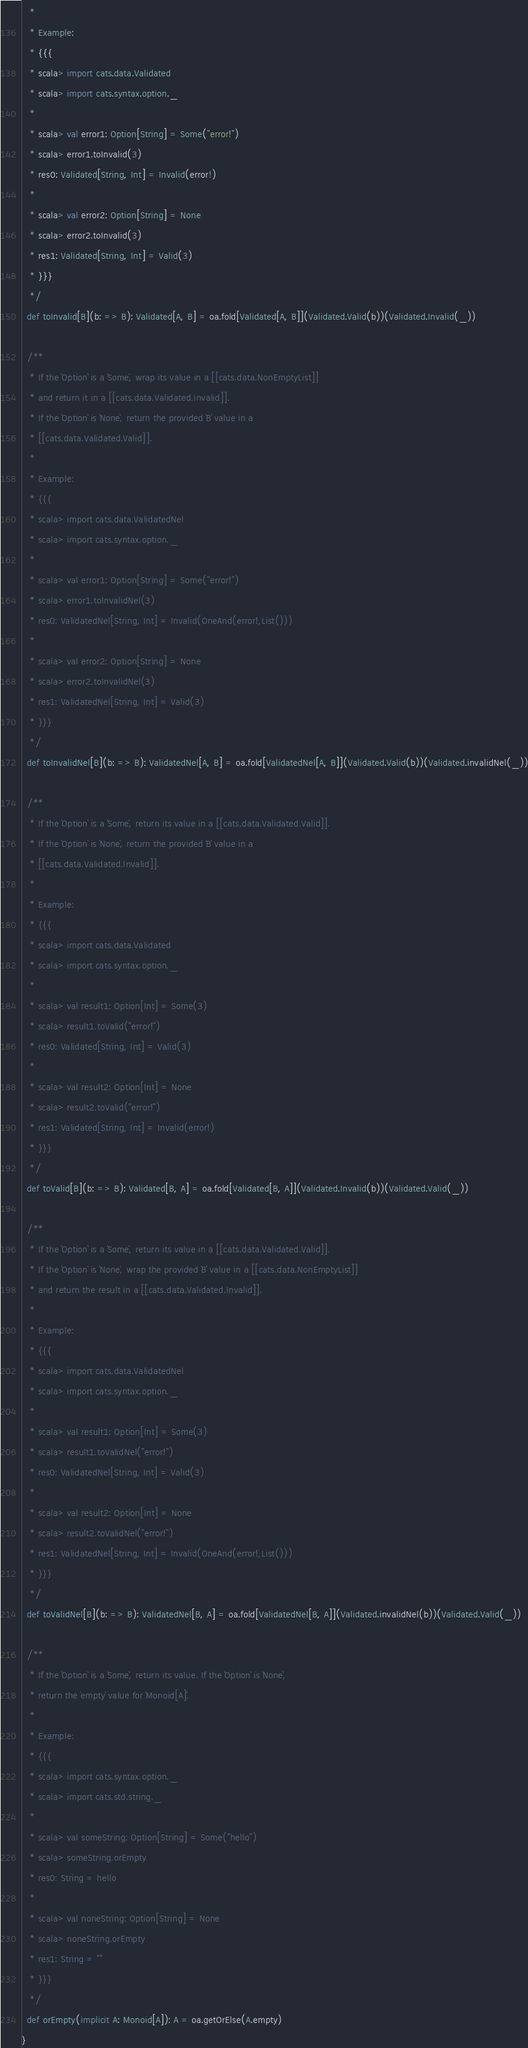Convert code to text. <code><loc_0><loc_0><loc_500><loc_500><_Scala_>   *
   * Example:
   * {{{
   * scala> import cats.data.Validated
   * scala> import cats.syntax.option._
   *
   * scala> val error1: Option[String] = Some("error!")
   * scala> error1.toInvalid(3)
   * res0: Validated[String, Int] = Invalid(error!)
   *
   * scala> val error2: Option[String] = None
   * scala> error2.toInvalid(3)
   * res1: Validated[String, Int] = Valid(3)
   * }}}
   */
  def toInvalid[B](b: => B): Validated[A, B] = oa.fold[Validated[A, B]](Validated.Valid(b))(Validated.Invalid(_))

  /**
   * If the `Option` is a `Some`, wrap its value in a [[cats.data.NonEmptyList]]
   * and return it in a [[cats.data.Validated.Invalid]].
   * If the `Option` is `None`, return the provided `B` value in a
   * [[cats.data.Validated.Valid]].
   *
   * Example:
   * {{{
   * scala> import cats.data.ValidatedNel
   * scala> import cats.syntax.option._
   *
   * scala> val error1: Option[String] = Some("error!")
   * scala> error1.toInvalidNel(3)
   * res0: ValidatedNel[String, Int] = Invalid(OneAnd(error!,List()))
   *
   * scala> val error2: Option[String] = None
   * scala> error2.toInvalidNel(3)
   * res1: ValidatedNel[String, Int] = Valid(3)
   * }}}
   */
  def toInvalidNel[B](b: => B): ValidatedNel[A, B] = oa.fold[ValidatedNel[A, B]](Validated.Valid(b))(Validated.invalidNel(_))

  /**
   * If the `Option` is a `Some`, return its value in a [[cats.data.Validated.Valid]].
   * If the `Option` is `None`, return the provided `B` value in a
   * [[cats.data.Validated.Invalid]].
   *
   * Example:
   * {{{
   * scala> import cats.data.Validated
   * scala> import cats.syntax.option._
   *
   * scala> val result1: Option[Int] = Some(3)
   * scala> result1.toValid("error!")
   * res0: Validated[String, Int] = Valid(3)
   *
   * scala> val result2: Option[Int] = None
   * scala> result2.toValid("error!")
   * res1: Validated[String, Int] = Invalid(error!)
   * }}}
   */
  def toValid[B](b: => B): Validated[B, A] = oa.fold[Validated[B, A]](Validated.Invalid(b))(Validated.Valid(_))

  /**
   * If the `Option` is a `Some`, return its value in a [[cats.data.Validated.Valid]].
   * If the `Option` is `None`, wrap the provided `B` value in a [[cats.data.NonEmptyList]]
   * and return the result in a [[cats.data.Validated.Invalid]].
   *
   * Example:
   * {{{
   * scala> import cats.data.ValidatedNel
   * scala> import cats.syntax.option._
   *
   * scala> val result1: Option[Int] = Some(3)
   * scala> result1.toValidNel("error!")
   * res0: ValidatedNel[String, Int] = Valid(3)
   *
   * scala> val result2: Option[Int] = None
   * scala> result2.toValidNel("error!")
   * res1: ValidatedNel[String, Int] = Invalid(OneAnd(error!,List()))
   * }}}
   */
  def toValidNel[B](b: => B): ValidatedNel[B, A] = oa.fold[ValidatedNel[B, A]](Validated.invalidNel(b))(Validated.Valid(_))

  /**
   * If the `Option` is a `Some`, return its value. If the `Option` is `None`,
   * return the `empty` value for `Monoid[A]`.
   *
   * Example:
   * {{{
   * scala> import cats.syntax.option._
   * scala> import cats.std.string._
   *
   * scala> val someString: Option[String] = Some("hello")
   * scala> someString.orEmpty
   * res0: String = hello
   *
   * scala> val noneString: Option[String] = None
   * scala> noneString.orEmpty
   * res1: String = ""
   * }}}
   */
  def orEmpty(implicit A: Monoid[A]): A = oa.getOrElse(A.empty)
}
</code> 